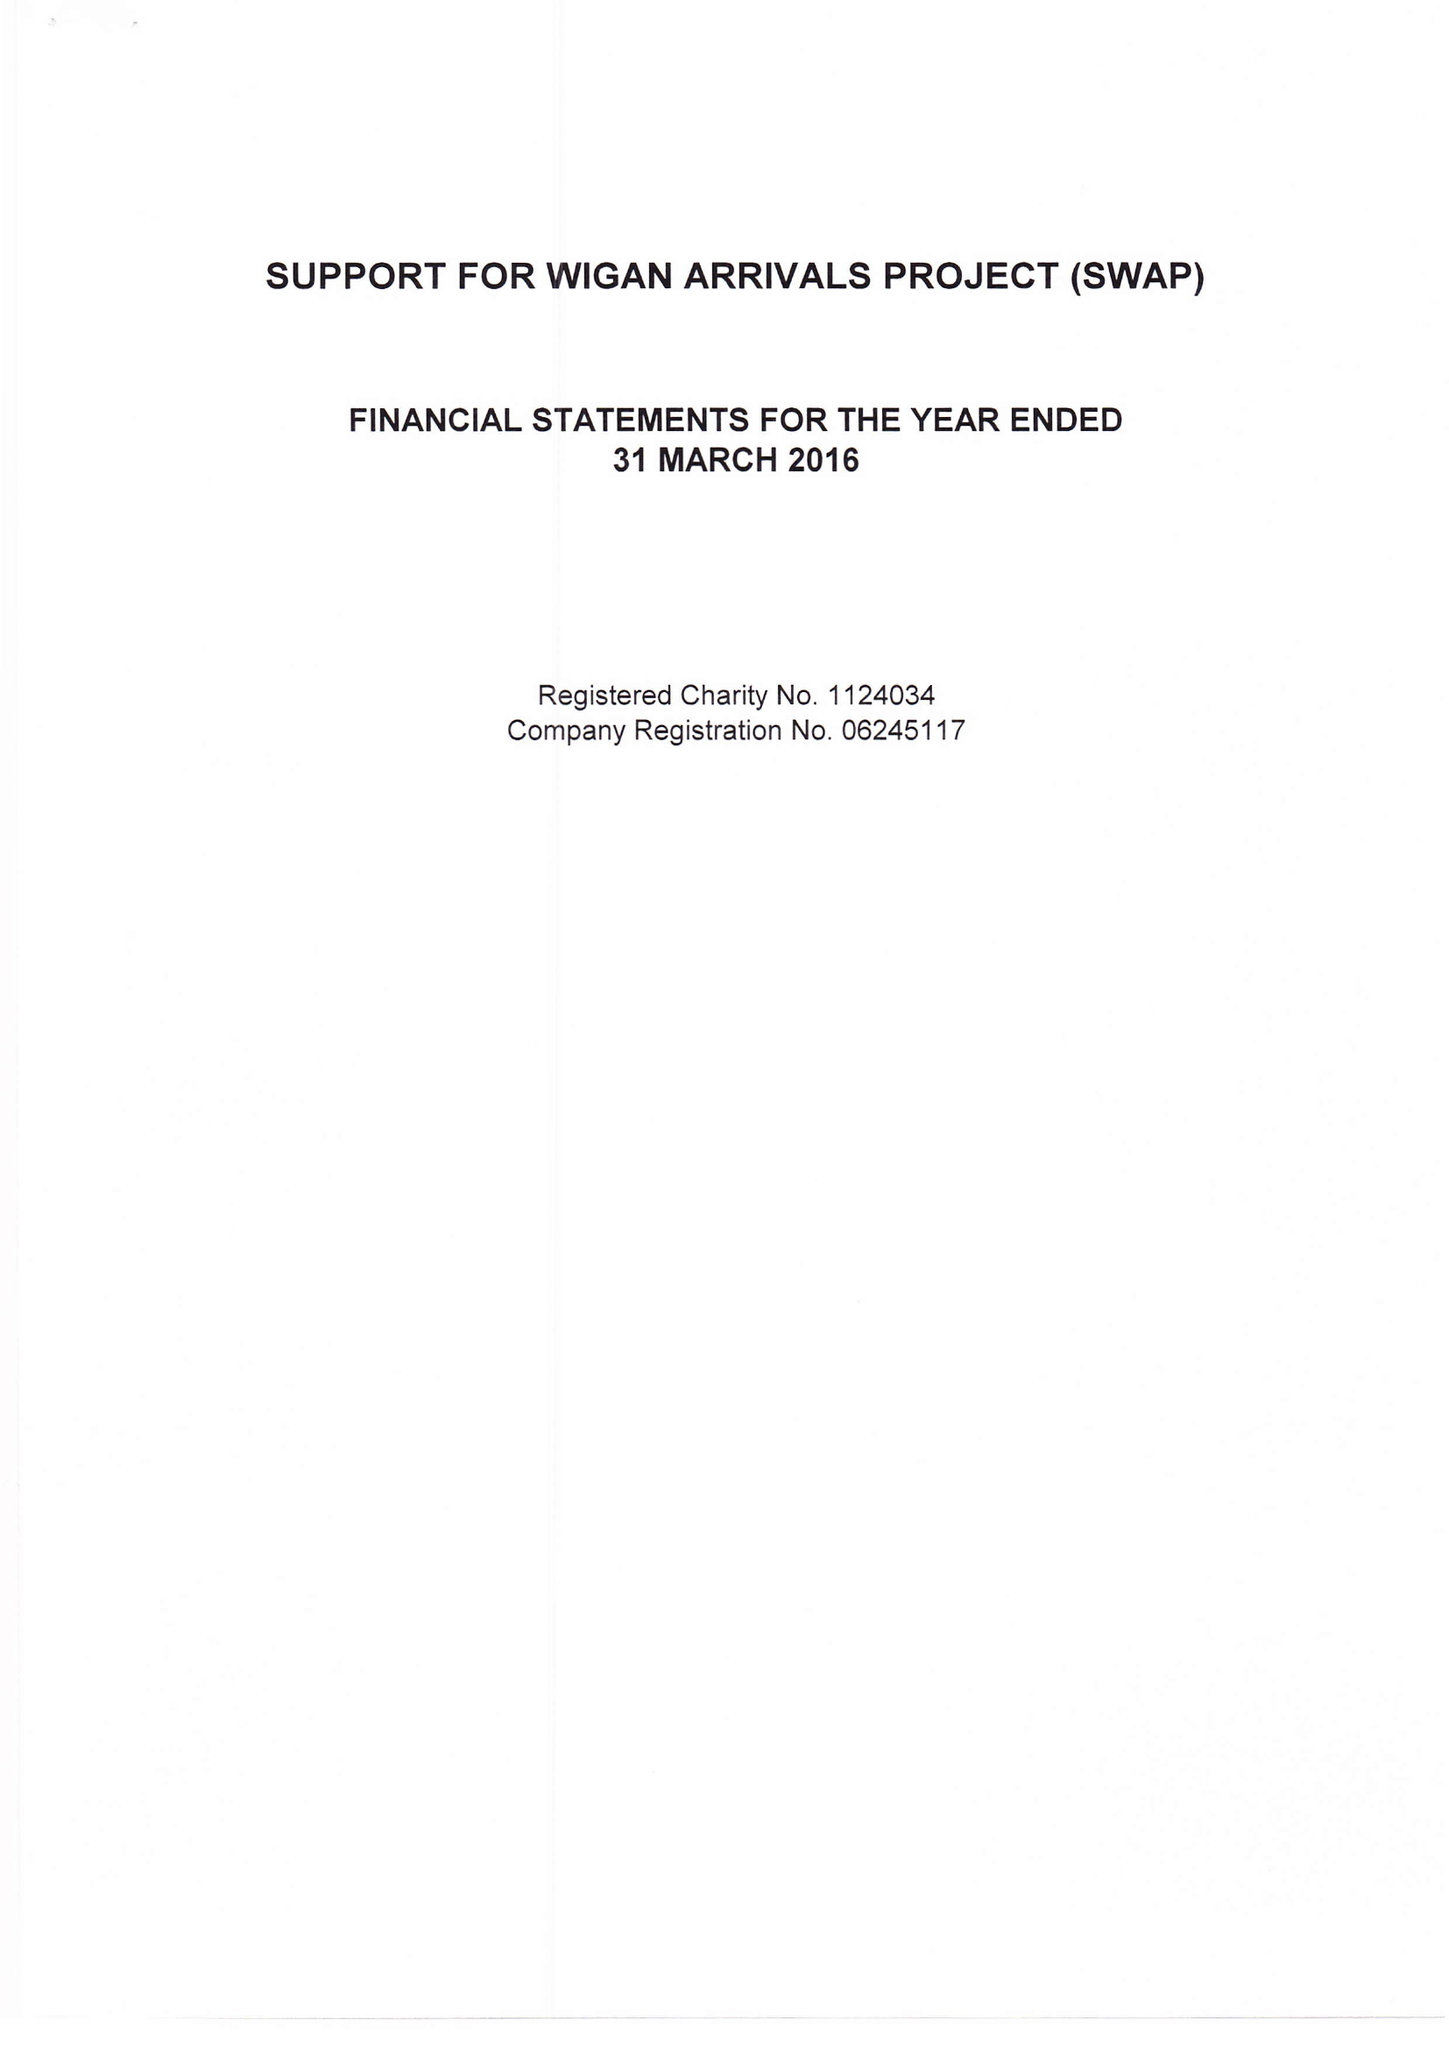What is the value for the charity_number?
Answer the question using a single word or phrase. 1124034 